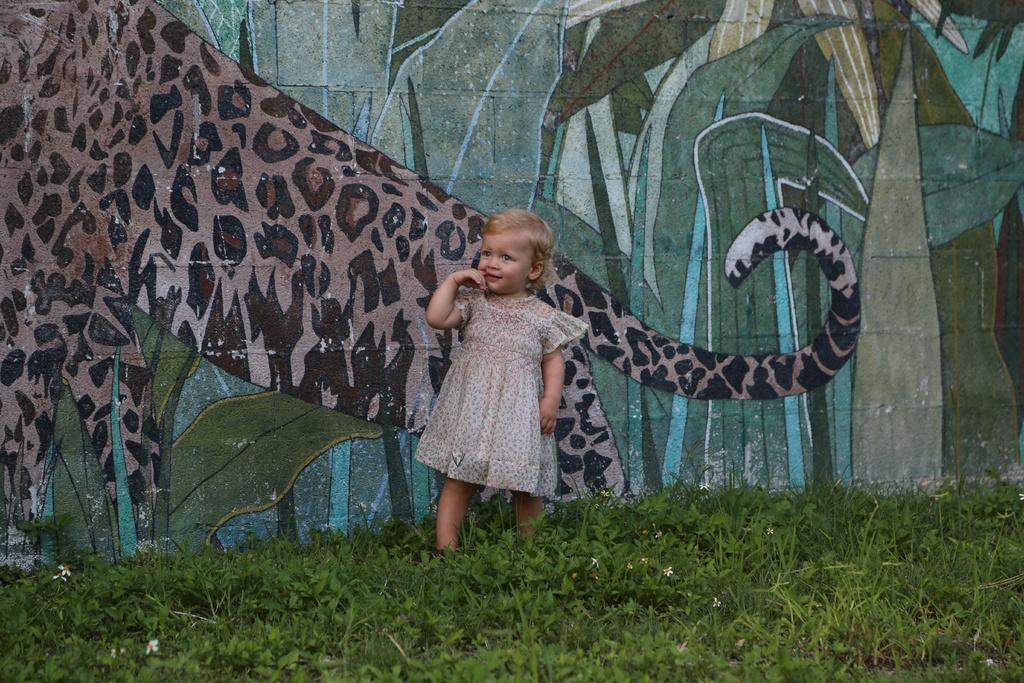What is the main subject in the image? There is a girl standing in the image. What can be seen on the wall in the image? There is a painting on the wall in the image. What type of vegetation is present in the image? There is green grass in the image. What type of key is the girl holding in the image? There is no key present in the image; the girl is not holding anything. 